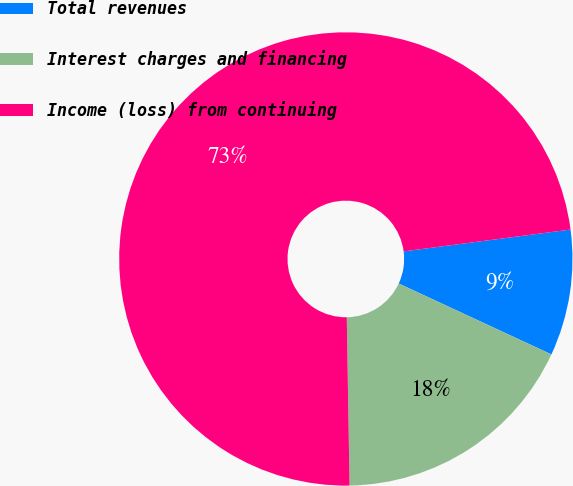<chart> <loc_0><loc_0><loc_500><loc_500><pie_chart><fcel>Total revenues<fcel>Interest charges and financing<fcel>Income (loss) from continuing<nl><fcel>8.99%<fcel>17.82%<fcel>73.19%<nl></chart> 